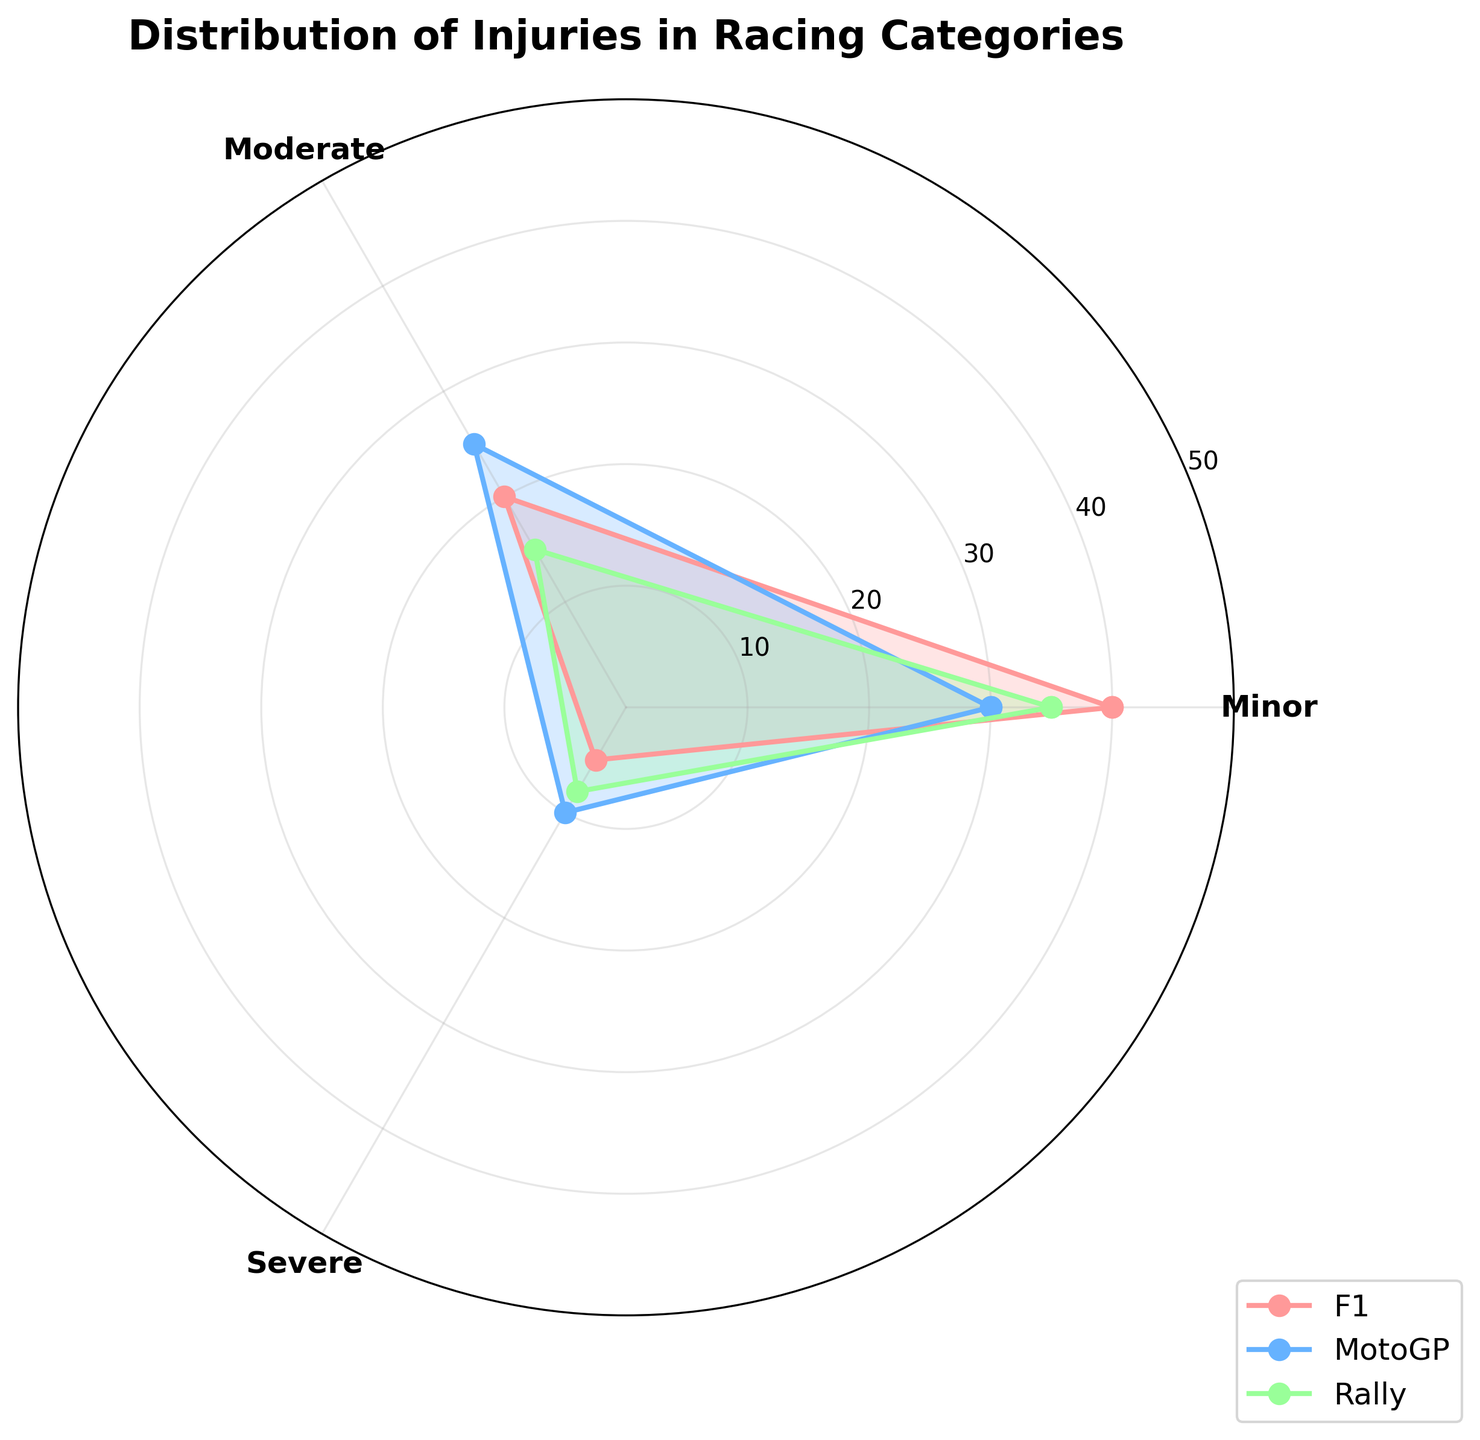What is the title of the plot? The title is typically placed at the top of the chart, centered and slightly larger than other text elements. The plot title helps to provide context and summarize the information contained in the figure.
Answer: Distribution of Injuries in Racing Categories How many categories of injuries are shown in the plot? By looking at the radial axis labels or segments of the rose chart, you can notice that the categories of injuries are represented. Count the unique segments.
Answer: 3 (Minor, Moderate, Severe) Which racing category shows the highest count of minor injuries? Observe the radial distance of the segments labeled 'Minor' for each racing category (F1, MotoGP, Rally). The one with the longest radial segment corresponds to the highest count.
Answer: F1 What is the combined count of severe injuries across all racing categories? To find this, sum the counts of severe injuries from all racing categories: F1 (5), MotoGP (10), and Rally (8).
Answer: 23 Which injury severity is most common in MotoGP? Look at the counts for each injury severity within the MotoGP category (Minor, Moderate, Severe) and identify the one with the highest count.
Answer: Moderate How does the count of moderate injuries in Rally compare to the count of minor injuries in F1? Compare the radial lengths of the segments labeled 'Moderate' in Rally and 'Minor' in F1. State which count is higher.
Answer: Minor injuries in F1 are higher What are the counts of minor and moderate injuries in F1, and what is their combined total? Identify the counts next to the 'Minor' and 'Moderate' segments for F1. Sum these counts to get the combined total.
Answer: Minor: 40, Moderate: 20, Combined: 60 Is there any racing category where severe injuries exceed moderate injuries? Compare the radial lengths for 'Severe' and 'Moderate' in each category. Check if the 'Severe' segment is ever longer than the 'Moderate' segment.
Answer: No How does the number of moderate injuries in MotoGP compare to the number of severe injuries in Rally? Compare the radial lengths corresponding to 'Moderate' in MotoGP and 'Severe' in Rally to determine which is larger.
Answer: Moderate injuries in MotoGP are higher What is the average count of minor injuries across the three racing categories? To find this, add the counts of minor injuries across each category: F1 (40), MotoGP (30), Rally (35). Then, divide by the number of categories (3).
Answer: (40 + 30 + 35) / 3 = 35 